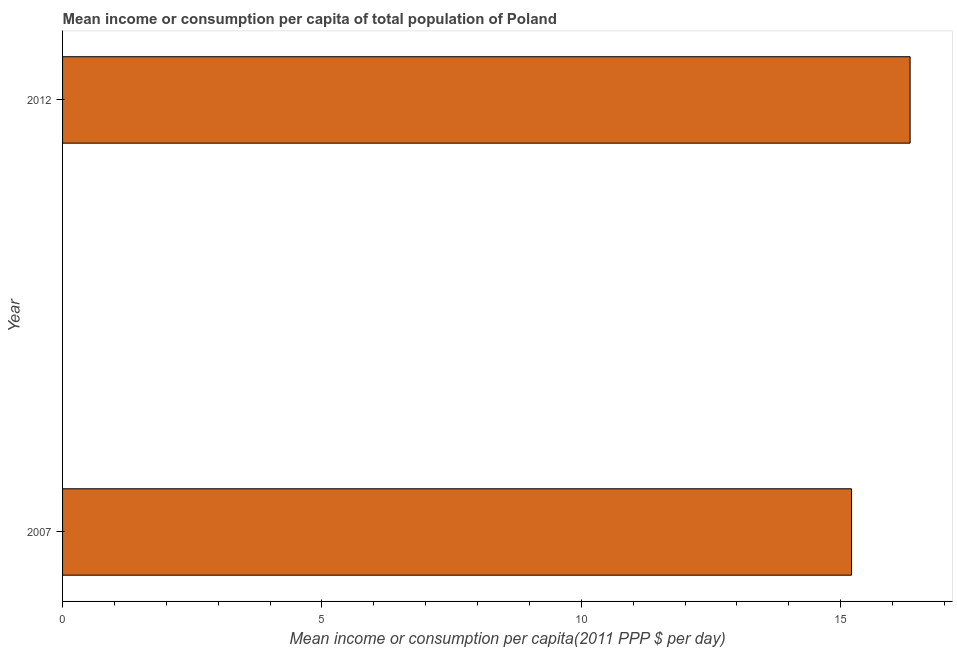Does the graph contain grids?
Give a very brief answer. No. What is the title of the graph?
Ensure brevity in your answer.  Mean income or consumption per capita of total population of Poland. What is the label or title of the X-axis?
Keep it short and to the point. Mean income or consumption per capita(2011 PPP $ per day). What is the mean income or consumption in 2007?
Your response must be concise. 15.21. Across all years, what is the maximum mean income or consumption?
Offer a very short reply. 16.34. Across all years, what is the minimum mean income or consumption?
Provide a short and direct response. 15.21. In which year was the mean income or consumption maximum?
Ensure brevity in your answer.  2012. In which year was the mean income or consumption minimum?
Ensure brevity in your answer.  2007. What is the sum of the mean income or consumption?
Offer a very short reply. 31.55. What is the difference between the mean income or consumption in 2007 and 2012?
Ensure brevity in your answer.  -1.13. What is the average mean income or consumption per year?
Your answer should be very brief. 15.78. What is the median mean income or consumption?
Your response must be concise. 15.78. In how many years, is the mean income or consumption greater than 7 $?
Give a very brief answer. 2. Is the mean income or consumption in 2007 less than that in 2012?
Provide a short and direct response. Yes. In how many years, is the mean income or consumption greater than the average mean income or consumption taken over all years?
Your answer should be very brief. 1. How many years are there in the graph?
Make the answer very short. 2. Are the values on the major ticks of X-axis written in scientific E-notation?
Your answer should be compact. No. What is the Mean income or consumption per capita(2011 PPP $ per day) in 2007?
Your answer should be compact. 15.21. What is the Mean income or consumption per capita(2011 PPP $ per day) of 2012?
Provide a short and direct response. 16.34. What is the difference between the Mean income or consumption per capita(2011 PPP $ per day) in 2007 and 2012?
Offer a terse response. -1.13. What is the ratio of the Mean income or consumption per capita(2011 PPP $ per day) in 2007 to that in 2012?
Ensure brevity in your answer.  0.93. 